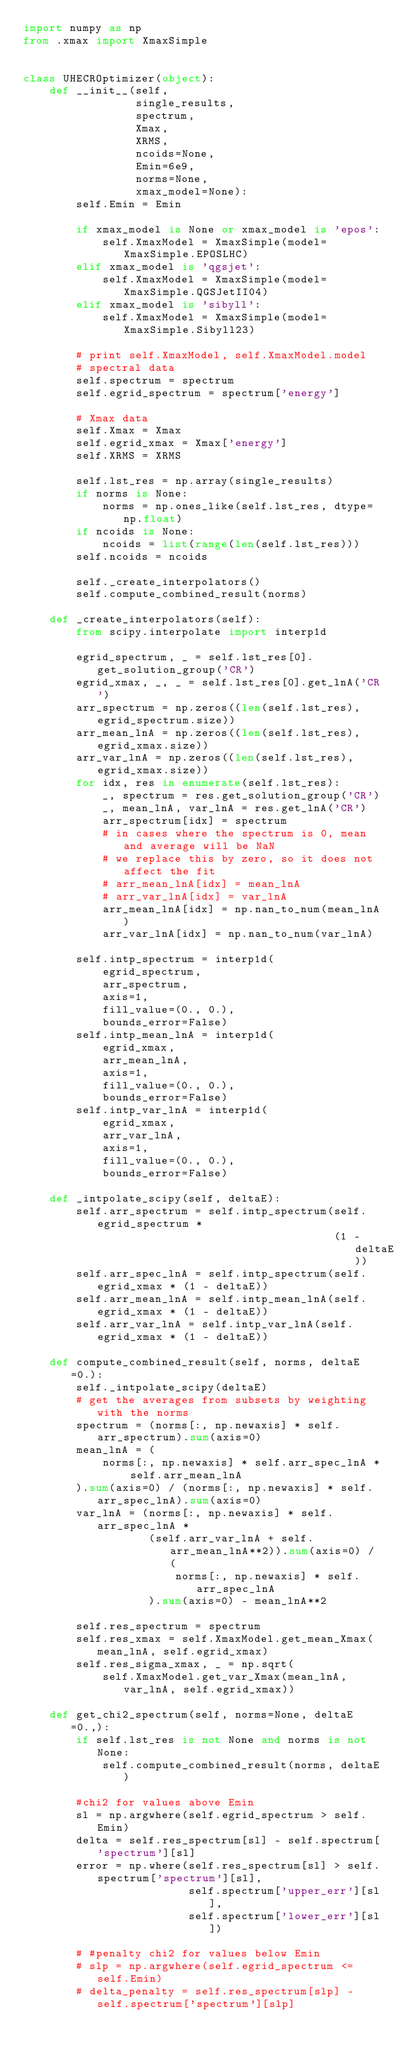<code> <loc_0><loc_0><loc_500><loc_500><_Python_>import numpy as np
from .xmax import XmaxSimple


class UHECROptimizer(object):
    def __init__(self,
                 single_results,
                 spectrum,
                 Xmax,
                 XRMS,
                 ncoids=None,
                 Emin=6e9,
                 norms=None,
                 xmax_model=None):
        self.Emin = Emin

        if xmax_model is None or xmax_model is 'epos':
            self.XmaxModel = XmaxSimple(model=XmaxSimple.EPOSLHC)
        elif xmax_model is 'qgsjet':
            self.XmaxModel = XmaxSimple(model=XmaxSimple.QGSJetII04)
        elif xmax_model is 'sibyll':
            self.XmaxModel = XmaxSimple(model=XmaxSimple.Sibyll23)

        # print self.XmaxModel, self.XmaxModel.model
        # spectral data
        self.spectrum = spectrum
        self.egrid_spectrum = spectrum['energy']

        # Xmax data
        self.Xmax = Xmax
        self.egrid_xmax = Xmax['energy']
        self.XRMS = XRMS

        self.lst_res = np.array(single_results)
        if norms is None:
            norms = np.ones_like(self.lst_res, dtype=np.float)
        if ncoids is None:
            ncoids = list(range(len(self.lst_res)))
        self.ncoids = ncoids

        self._create_interpolators()
        self.compute_combined_result(norms)

    def _create_interpolators(self):
        from scipy.interpolate import interp1d

        egrid_spectrum, _ = self.lst_res[0].get_solution_group('CR')
        egrid_xmax, _, _ = self.lst_res[0].get_lnA('CR')
        arr_spectrum = np.zeros((len(self.lst_res), egrid_spectrum.size))
        arr_mean_lnA = np.zeros((len(self.lst_res), egrid_xmax.size))
        arr_var_lnA = np.zeros((len(self.lst_res), egrid_xmax.size))
        for idx, res in enumerate(self.lst_res):
            _, spectrum = res.get_solution_group('CR')
            _, mean_lnA, var_lnA = res.get_lnA('CR')
            arr_spectrum[idx] = spectrum
            # in cases where the spectrum is 0, mean and average will be NaN
            # we replace this by zero, so it does not affect the fit
            # arr_mean_lnA[idx] = mean_lnA
            # arr_var_lnA[idx] = var_lnA
            arr_mean_lnA[idx] = np.nan_to_num(mean_lnA)
            arr_var_lnA[idx] = np.nan_to_num(var_lnA)

        self.intp_spectrum = interp1d(
            egrid_spectrum,
            arr_spectrum,
            axis=1,
            fill_value=(0., 0.),
            bounds_error=False)
        self.intp_mean_lnA = interp1d(
            egrid_xmax,
            arr_mean_lnA,
            axis=1,
            fill_value=(0., 0.),
            bounds_error=False)
        self.intp_var_lnA = interp1d(
            egrid_xmax,
            arr_var_lnA,
            axis=1,
            fill_value=(0., 0.),
            bounds_error=False)

    def _intpolate_scipy(self, deltaE):
        self.arr_spectrum = self.intp_spectrum(self.egrid_spectrum *
                                               (1 - deltaE))
        self.arr_spec_lnA = self.intp_spectrum(self.egrid_xmax * (1 - deltaE))
        self.arr_mean_lnA = self.intp_mean_lnA(self.egrid_xmax * (1 - deltaE))
        self.arr_var_lnA = self.intp_var_lnA(self.egrid_xmax * (1 - deltaE))

    def compute_combined_result(self, norms, deltaE=0.):
        self._intpolate_scipy(deltaE)
        # get the averages from subsets by weighting with the norms
        spectrum = (norms[:, np.newaxis] * self.arr_spectrum).sum(axis=0)
        mean_lnA = (
            norms[:, np.newaxis] * self.arr_spec_lnA * self.arr_mean_lnA
        ).sum(axis=0) / (norms[:, np.newaxis] * self.arr_spec_lnA).sum(axis=0)
        var_lnA = (norms[:, np.newaxis] * self.arr_spec_lnA *
                   (self.arr_var_lnA + self.arr_mean_lnA**2)).sum(axis=0) / (
                       norms[:, np.newaxis] * self.arr_spec_lnA
                   ).sum(axis=0) - mean_lnA**2

        self.res_spectrum = spectrum
        self.res_xmax = self.XmaxModel.get_mean_Xmax(mean_lnA, self.egrid_xmax)
        self.res_sigma_xmax, _ = np.sqrt(
            self.XmaxModel.get_var_Xmax(mean_lnA, var_lnA, self.egrid_xmax))

    def get_chi2_spectrum(self, norms=None, deltaE=0.,):
        if self.lst_res is not None and norms is not None:
            self.compute_combined_result(norms, deltaE)

        #chi2 for values above Emin
        sl = np.argwhere(self.egrid_spectrum > self.Emin)
        delta = self.res_spectrum[sl] - self.spectrum['spectrum'][sl]
        error = np.where(self.res_spectrum[sl] > self.spectrum['spectrum'][sl],
                         self.spectrum['upper_err'][sl],
                         self.spectrum['lower_err'][sl])

        # #penalty chi2 for values below Emin
        # slp = np.argwhere(self.egrid_spectrum <= self.Emin)
        # delta_penalty = self.res_spectrum[slp] - self.spectrum['spectrum'][slp]</code> 